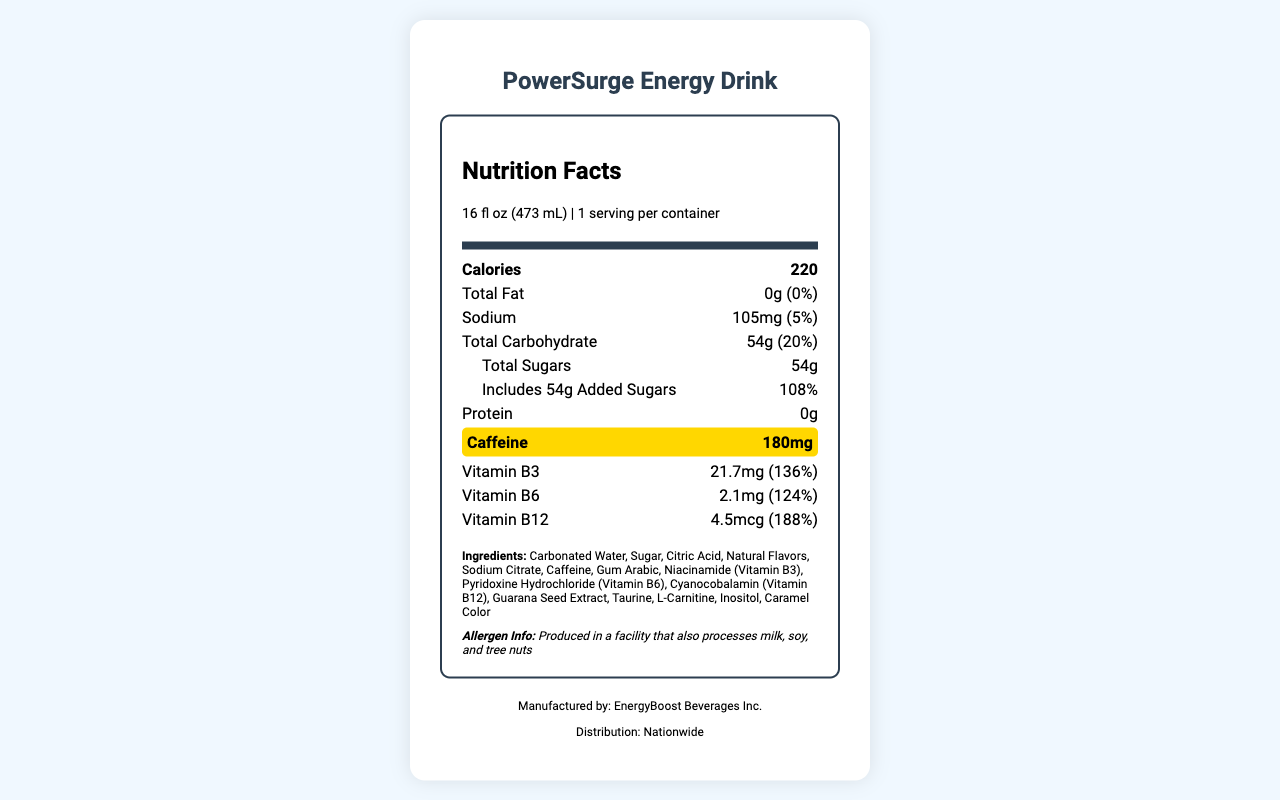what is the serving size of PowerSurge Energy Drink? The serving size is clearly listed at the top of the nutrition label under the section that says "serving size."
Answer: 16 fl oz (473 mL) how many calories are in a container of this energy drink? The calories are stated directly in the nutrition facts section as 220.
Answer: 220 what percentage of the daily value of total carbohydrates does one serving of this drink provide? The document mentions that the total carbohydrate content is 54g, which is 20% of the daily value.
Answer: 20% how much caffeine is in the PowerSurge Energy Drink? The caffeine content is highlighted in the document with a background color and is listed as 180mg.
Answer: 180mg what is the total fat content in this drink? The total fat content is indicated as 0g with no daily value percentage.
Answer: 0g how many servings are in one container of the drink? The document states that there is 1 serving per container.
Answer: 1 how much sodium does PowerSurge Energy Drink have? The sodium content is stated as 105mg in the nutrition information.
Answer: 105mg from which vitamin does this drink provide the highest percentage of daily value? The document lists Vitamin B12 as providing 188% of the daily value.
Answer: Vitamin B12 what is the main ingredient in this energy drink? The first ingredient listed in the ingredients section is Carbonated Water, which typically indicates that it's the main ingredient.
Answer: Carbonated Water how much added sugar is in this drink? The document clearly states that the drink includes 54g of added sugars.
Answer: 54g which of the following vitamins is NOT included in this drink: A. Vitamin B3 B. Vitamin C C. Vitamin B6 D. Vitamin B12 The document lists Vitamin B3, Vitamin B6, and Vitamin B12 but does not list Vitamin C.
Answer: B. Vitamin C how many mg of vitamin B3 does this drink contain? The drink contains 21.7mg of Vitamin B3 as stated in the document.
Answer: 21.7mg is there any protein in the PowerSurge Energy Drink? The nutrition facts label shows 0g of protein, so there is no protein in the drink.
Answer: No what is the allergen information for this energy drink? The allergen information is stated under the ingredients list and indicates potential cross-contamination with milk, soy, and tree nuts.
Answer: Produced in a facility that also processes milk, soy, and tree nuts list three ingredients found in PowerSurge Energy Drink. These ingredients are part of the list provided in the document.
Answer: Sugar, Citric Acid, Niacinamide (Vitamin B3) how is caffeine content highlighted in the document? The document highlights the caffeine content with a background color to draw attention to it.
Answer: With a background color compare the daily values of vitamin B3, vitamin B6, and vitamin B12. The document lists the daily values for Vitamin B3, Vitamin B6, and Vitamin B12 as 136%, 124%, and 188% respectively.
Answer: Vitamin B3: 136%, Vitamin B6: 124%, Vitamin B12: 188% summarize the document. The document focuses on conveying the nutritional content and ingredients of an energy drink named PowerSurge, along with essential information about its production and distribution.
Answer: This document provides detailed nutrition information for PowerSurge Energy Drink, including serving size, calories, macronutrient content, and vitamins. It highlights the caffeine content and lists the ingredients, allergen information, and manufacturer. which company manufactures PowerSurge Energy Drink? The manufacturer information is provided at the bottom of the document.
Answer: EnergyBoost Beverages Inc. how can I track the correlation between caffeine content and sales data according to the data analysis tips? One of the data analysis tips specifically suggests tracking sales data alongside caffeine content to identify any correlation.
Answer: Track sales data alongside caffeine content to identify correlation what impact do marketing campaigns have on sales volume according to the document? The document lists this as a suggested analysis but does not provide specific information or data on the impact of marketing campaigns on sales volume.
Answer: Not enough information 